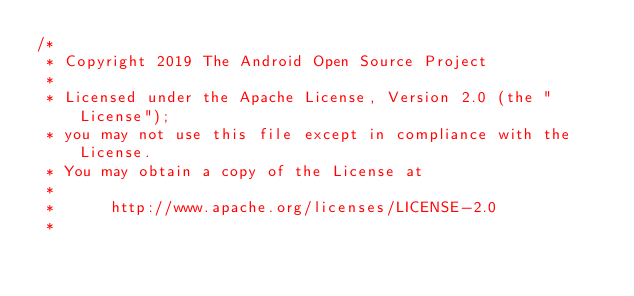<code> <loc_0><loc_0><loc_500><loc_500><_Kotlin_>/*
 * Copyright 2019 The Android Open Source Project
 *
 * Licensed under the Apache License, Version 2.0 (the "License");
 * you may not use this file except in compliance with the License.
 * You may obtain a copy of the License at
 *
 *      http://www.apache.org/licenses/LICENSE-2.0
 *</code> 